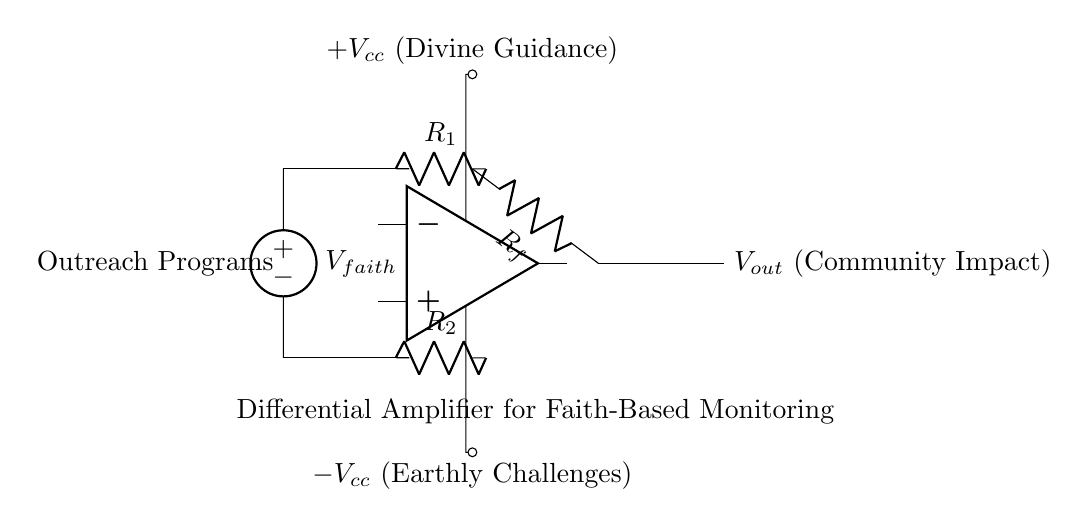What type of circuit is represented here? This circuit is identified as a differential amplifier. It is designed to amplify the difference between two input signals, which is characteristic of differential amplifiers.
Answer: differential amplifier What do the symbols representing $V_{cc}$ denote? The $V_{cc}$ symbols indicate power supply voltages. The positive $V_{cc}$ represents divine guidance, while the negative $V_{cc}$ represents earthly challenges, reflecting the theme of faith.
Answer: divine guidance and earthly challenges What is the purpose of resistors $R_1$ and $R_2$? Resistors $R_1$ and $R_2$ are used to set the gain of the amplifier and help in determining the input impedance. They create a voltage divider for the input signals.
Answer: gain control What does the output $V_{out}$ symbolize? The output $V_{out}$ indicates the community impact derived from the amplified difference between the input signals, measuring the effectiveness of outreach programs.
Answer: community impact How does the differential amplifier process input signals? The amplifier processes input signals by taking the difference between $V_{faith}$ from the outreach programs and the other input signal, amplifying that difference to produce the output voltage.
Answer: amplifies difference What is the significance of resistor $R_f$? Resistor $R_f$ is a feedback resistor that influences the gain of the differential amplifier. It determines how much feedback is provided to the input stage, affecting the overall amplification factor.
Answer: gain control 